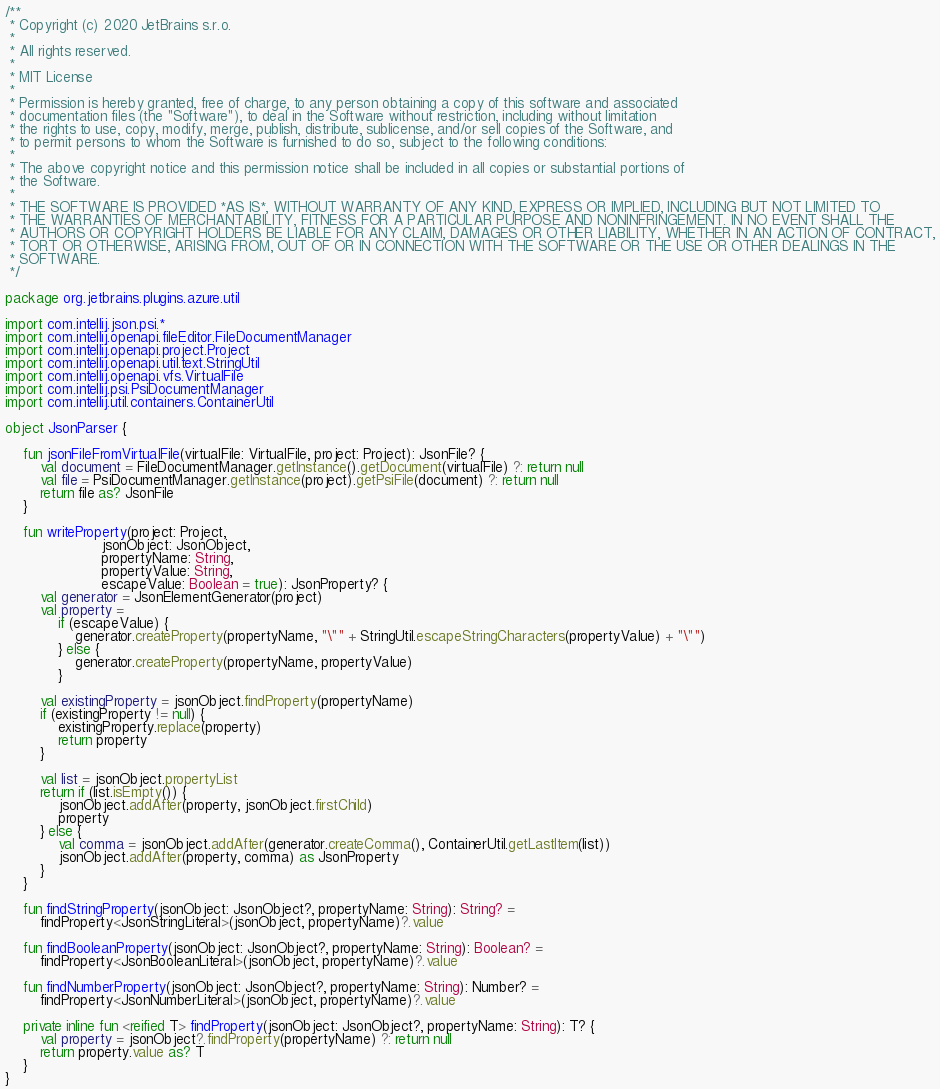<code> <loc_0><loc_0><loc_500><loc_500><_Kotlin_>/**
 * Copyright (c) 2020 JetBrains s.r.o.
 *
 * All rights reserved.
 *
 * MIT License
 *
 * Permission is hereby granted, free of charge, to any person obtaining a copy of this software and associated
 * documentation files (the "Software"), to deal in the Software without restriction, including without limitation
 * the rights to use, copy, modify, merge, publish, distribute, sublicense, and/or sell copies of the Software, and
 * to permit persons to whom the Software is furnished to do so, subject to the following conditions:
 *
 * The above copyright notice and this permission notice shall be included in all copies or substantial portions of
 * the Software.
 *
 * THE SOFTWARE IS PROVIDED *AS IS*, WITHOUT WARRANTY OF ANY KIND, EXPRESS OR IMPLIED, INCLUDING BUT NOT LIMITED TO
 * THE WARRANTIES OF MERCHANTABILITY, FITNESS FOR A PARTICULAR PURPOSE AND NONINFRINGEMENT. IN NO EVENT SHALL THE
 * AUTHORS OR COPYRIGHT HOLDERS BE LIABLE FOR ANY CLAIM, DAMAGES OR OTHER LIABILITY, WHETHER IN AN ACTION OF CONTRACT,
 * TORT OR OTHERWISE, ARISING FROM, OUT OF OR IN CONNECTION WITH THE SOFTWARE OR THE USE OR OTHER DEALINGS IN THE
 * SOFTWARE.
 */

package org.jetbrains.plugins.azure.util

import com.intellij.json.psi.*
import com.intellij.openapi.fileEditor.FileDocumentManager
import com.intellij.openapi.project.Project
import com.intellij.openapi.util.text.StringUtil
import com.intellij.openapi.vfs.VirtualFile
import com.intellij.psi.PsiDocumentManager
import com.intellij.util.containers.ContainerUtil

object JsonParser {

    fun jsonFileFromVirtualFile(virtualFile: VirtualFile, project: Project): JsonFile? {
        val document = FileDocumentManager.getInstance().getDocument(virtualFile) ?: return null
        val file = PsiDocumentManager.getInstance(project).getPsiFile(document) ?: return null
        return file as? JsonFile
    }

    fun writeProperty(project: Project,
                      jsonObject: JsonObject,
                      propertyName: String,
                      propertyValue: String,
                      escapeValue: Boolean = true): JsonProperty? {
        val generator = JsonElementGenerator(project)
        val property =
            if (escapeValue) {
                generator.createProperty(propertyName, "\"" + StringUtil.escapeStringCharacters(propertyValue) + "\"")
            } else {
                generator.createProperty(propertyName, propertyValue)
            }

        val existingProperty = jsonObject.findProperty(propertyName)
        if (existingProperty != null) {
            existingProperty.replace(property)
            return property
        }

        val list = jsonObject.propertyList
        return if (list.isEmpty()) {
            jsonObject.addAfter(property, jsonObject.firstChild)
            property
        } else {
            val comma = jsonObject.addAfter(generator.createComma(), ContainerUtil.getLastItem(list))
            jsonObject.addAfter(property, comma) as JsonProperty
        }
    }

    fun findStringProperty(jsonObject: JsonObject?, propertyName: String): String? =
        findProperty<JsonStringLiteral>(jsonObject, propertyName)?.value

    fun findBooleanProperty(jsonObject: JsonObject?, propertyName: String): Boolean? =
        findProperty<JsonBooleanLiteral>(jsonObject, propertyName)?.value

    fun findNumberProperty(jsonObject: JsonObject?, propertyName: String): Number? =
        findProperty<JsonNumberLiteral>(jsonObject, propertyName)?.value

    private inline fun <reified T> findProperty(jsonObject: JsonObject?, propertyName: String): T? {
        val property = jsonObject?.findProperty(propertyName) ?: return null
        return property.value as? T
    }
}
</code> 